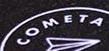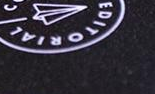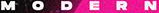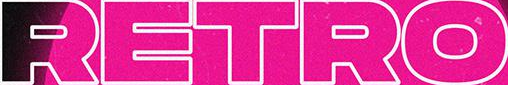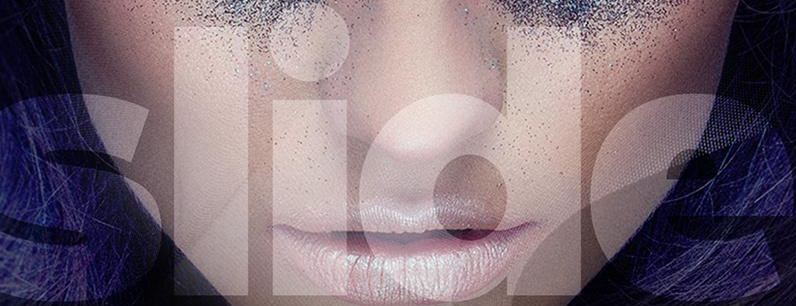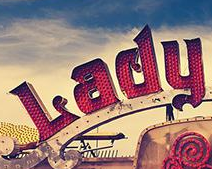Identify the words shown in these images in order, separated by a semicolon. COMETA; EDITORIAL; MODERN; RETRO; slide; Lady 